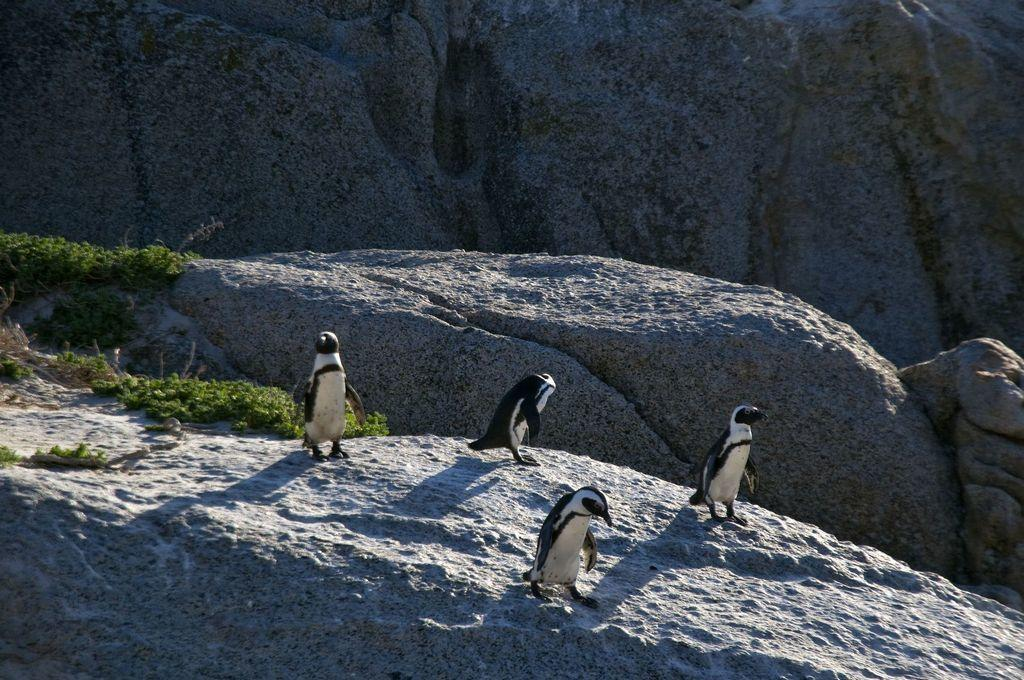How many penguins are in the image? There are four penguins in the image. What are the penguins doing in the image? The penguins are standing in the image. What type of vegetation can be seen on the left side of the image? There is grass on the left side of the image. What type of marble is being used by the penguins in the image? There is no marble present in the image; it features four penguins standing on grass. Can you tell me how the penguins are performing magic in the image? There is no magic being performed by the penguins in the image; they are simply standing. 